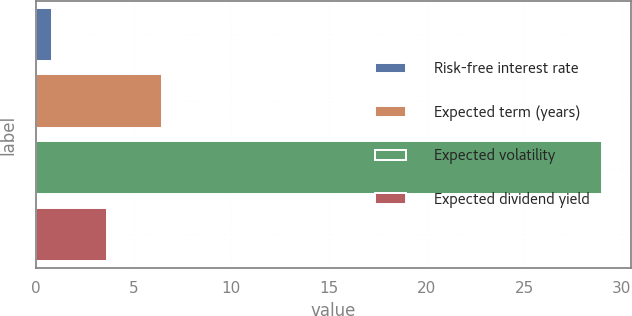Convert chart to OTSL. <chart><loc_0><loc_0><loc_500><loc_500><bar_chart><fcel>Risk-free interest rate<fcel>Expected term (years)<fcel>Expected volatility<fcel>Expected dividend yield<nl><fcel>0.8<fcel>6.44<fcel>29<fcel>3.62<nl></chart> 